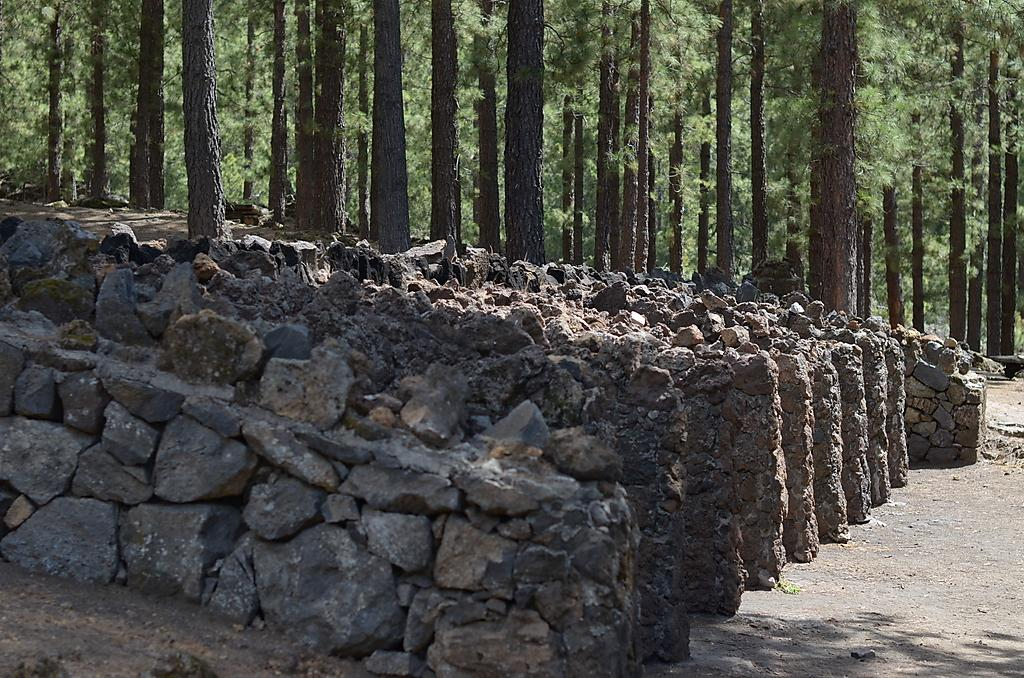What type of natural elements can be seen in the image? There are stones in the image. What can be seen on the right side of the image? There is a path on the right side of the image. What type of vegetation is visible in the background of the image? There are trees in the background of the image. What is the angle of the slope in the image? There is no slope present in the image; it features stones, a path, and trees. Can you tell me how many noses are visible in the image? There are no noses present in the image. 